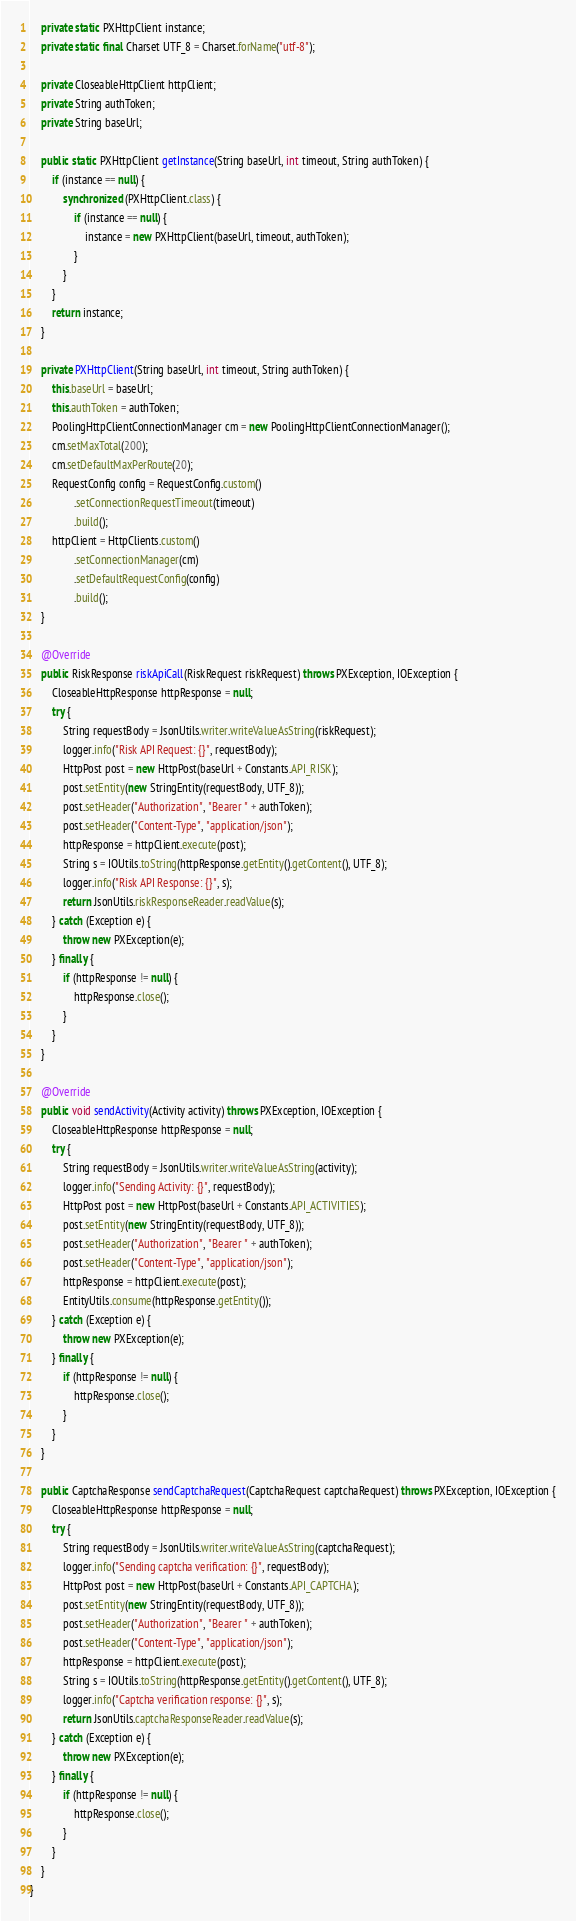<code> <loc_0><loc_0><loc_500><loc_500><_Java_>
    private static PXHttpClient instance;
    private static final Charset UTF_8 = Charset.forName("utf-8");

    private CloseableHttpClient httpClient;
    private String authToken;
    private String baseUrl;

    public static PXHttpClient getInstance(String baseUrl, int timeout, String authToken) {
        if (instance == null) {
            synchronized (PXHttpClient.class) {
                if (instance == null) {
                    instance = new PXHttpClient(baseUrl, timeout, authToken);
                }
            }
        }
        return instance;
    }

    private PXHttpClient(String baseUrl, int timeout, String authToken) {
        this.baseUrl = baseUrl;
        this.authToken = authToken;
        PoolingHttpClientConnectionManager cm = new PoolingHttpClientConnectionManager();
        cm.setMaxTotal(200);
        cm.setDefaultMaxPerRoute(20);
        RequestConfig config = RequestConfig.custom()
                .setConnectionRequestTimeout(timeout)
                .build();
        httpClient = HttpClients.custom()
                .setConnectionManager(cm)
                .setDefaultRequestConfig(config)
                .build();
    }

    @Override
    public RiskResponse riskApiCall(RiskRequest riskRequest) throws PXException, IOException {
        CloseableHttpResponse httpResponse = null;
        try {
            String requestBody = JsonUtils.writer.writeValueAsString(riskRequest);
            logger.info("Risk API Request: {}", requestBody);
            HttpPost post = new HttpPost(baseUrl + Constants.API_RISK);
            post.setEntity(new StringEntity(requestBody, UTF_8));
            post.setHeader("Authorization", "Bearer " + authToken);
            post.setHeader("Content-Type", "application/json");
            httpResponse = httpClient.execute(post);
            String s = IOUtils.toString(httpResponse.getEntity().getContent(), UTF_8);
            logger.info("Risk API Response: {}", s);
            return JsonUtils.riskResponseReader.readValue(s);
        } catch (Exception e) {
            throw new PXException(e);
        } finally {
            if (httpResponse != null) {
                httpResponse.close();
            }
        }
    }

    @Override
    public void sendActivity(Activity activity) throws PXException, IOException {
        CloseableHttpResponse httpResponse = null;
        try {
            String requestBody = JsonUtils.writer.writeValueAsString(activity);
            logger.info("Sending Activity: {}", requestBody);
            HttpPost post = new HttpPost(baseUrl + Constants.API_ACTIVITIES);
            post.setEntity(new StringEntity(requestBody, UTF_8));
            post.setHeader("Authorization", "Bearer " + authToken);
            post.setHeader("Content-Type", "application/json");
            httpResponse = httpClient.execute(post);
            EntityUtils.consume(httpResponse.getEntity());
        } catch (Exception e) {
            throw new PXException(e);
        } finally {
            if (httpResponse != null) {
                httpResponse.close();
            }
        }
    }

    public CaptchaResponse sendCaptchaRequest(CaptchaRequest captchaRequest) throws PXException, IOException {
        CloseableHttpResponse httpResponse = null;
        try {
            String requestBody = JsonUtils.writer.writeValueAsString(captchaRequest);
            logger.info("Sending captcha verification: {}", requestBody);
            HttpPost post = new HttpPost(baseUrl + Constants.API_CAPTCHA);
            post.setEntity(new StringEntity(requestBody, UTF_8));
            post.setHeader("Authorization", "Bearer " + authToken);
            post.setHeader("Content-Type", "application/json");
            httpResponse = httpClient.execute(post);
            String s = IOUtils.toString(httpResponse.getEntity().getContent(), UTF_8);
            logger.info("Captcha verification response: {}", s);
            return JsonUtils.captchaResponseReader.readValue(s);
        } catch (Exception e) {
            throw new PXException(e);
        } finally {
            if (httpResponse != null) {
                httpResponse.close();
            }
        }
    }
}
</code> 